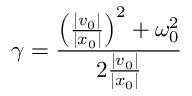<formula> <loc_0><loc_0><loc_500><loc_500>\gamma = \frac { \left ( \frac { | v _ { 0 } | } { | x _ { 0 } | } \right ) ^ { 2 } + \omega _ { 0 } ^ { 2 } } { 2 \frac { | v _ { 0 } | } { | x _ { 0 } | } } \,</formula> 